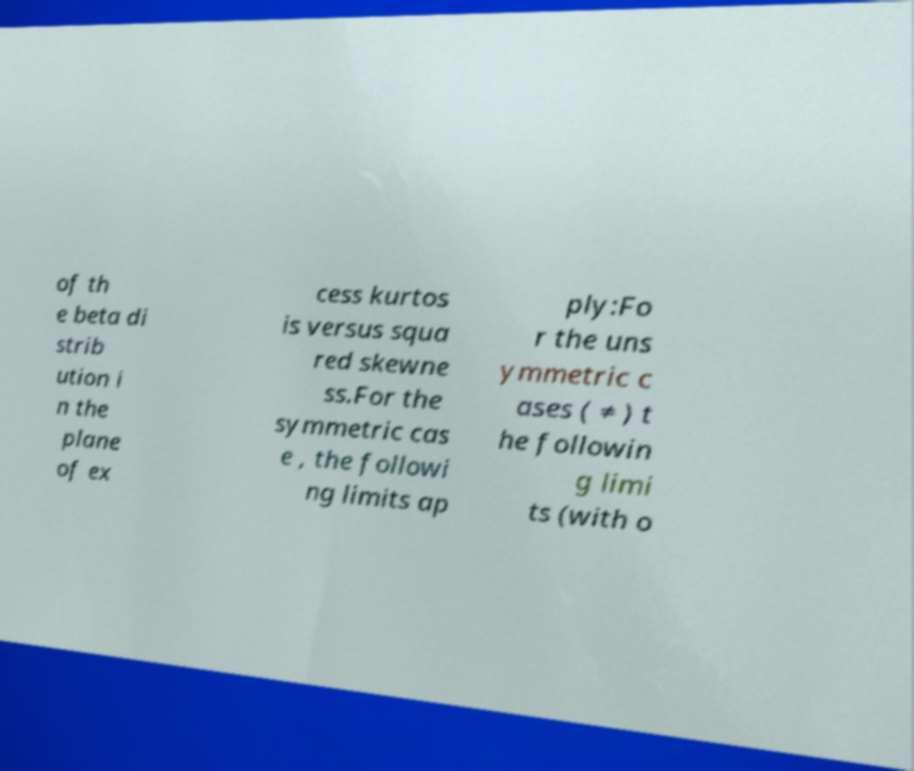Please identify and transcribe the text found in this image. of th e beta di strib ution i n the plane of ex cess kurtos is versus squa red skewne ss.For the symmetric cas e , the followi ng limits ap ply:Fo r the uns ymmetric c ases ( ≠ ) t he followin g limi ts (with o 